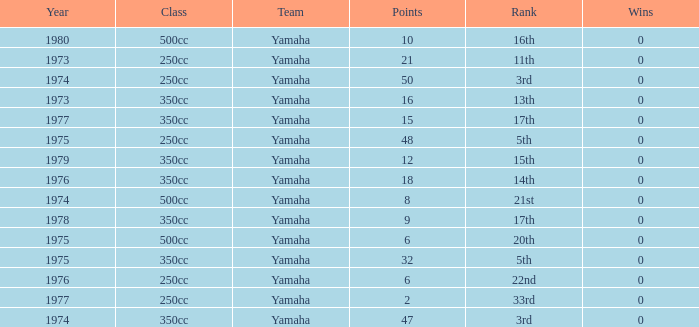In which races with a 500cc class did the wins take place prior to 1975? 0.0. 